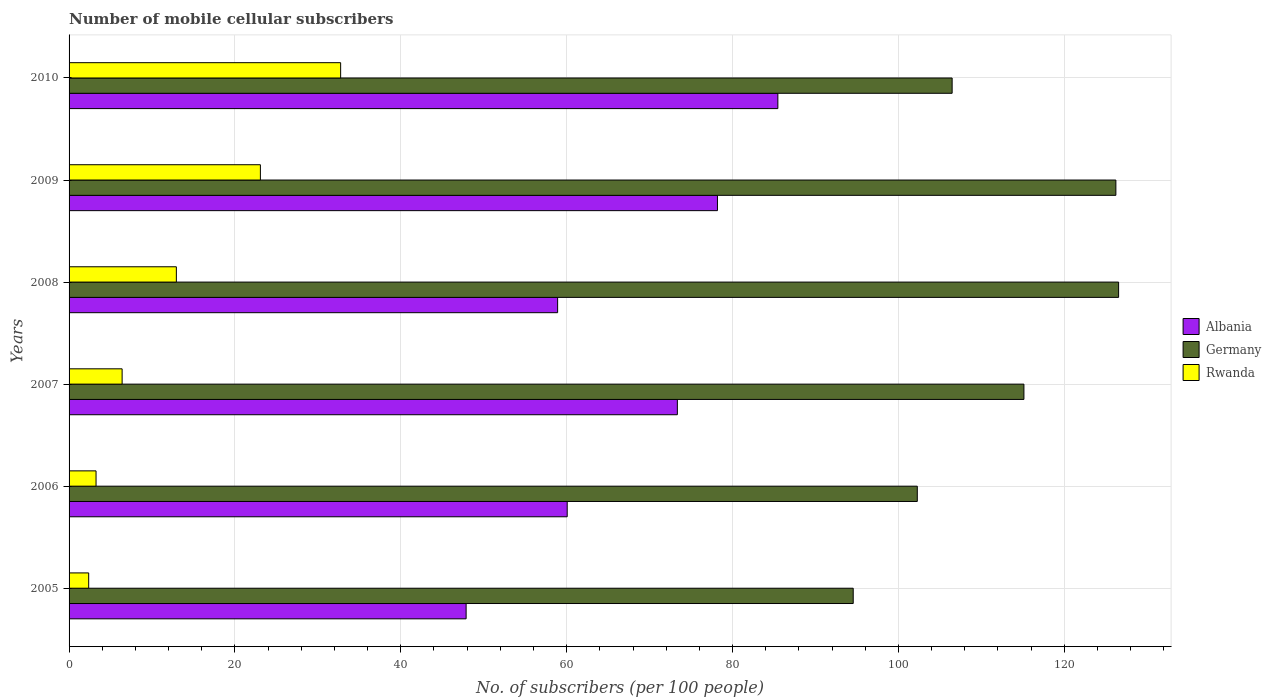How many different coloured bars are there?
Offer a terse response. 3. How many groups of bars are there?
Your response must be concise. 6. Are the number of bars per tick equal to the number of legend labels?
Offer a very short reply. Yes. Are the number of bars on each tick of the Y-axis equal?
Provide a short and direct response. Yes. What is the number of mobile cellular subscribers in Germany in 2009?
Offer a terse response. 126.23. Across all years, what is the maximum number of mobile cellular subscribers in Germany?
Keep it short and to the point. 126.56. Across all years, what is the minimum number of mobile cellular subscribers in Albania?
Your answer should be compact. 47.88. In which year was the number of mobile cellular subscribers in Germany maximum?
Offer a very short reply. 2008. In which year was the number of mobile cellular subscribers in Albania minimum?
Give a very brief answer. 2005. What is the total number of mobile cellular subscribers in Albania in the graph?
Provide a short and direct response. 403.86. What is the difference between the number of mobile cellular subscribers in Germany in 2007 and that in 2010?
Offer a very short reply. 8.66. What is the difference between the number of mobile cellular subscribers in Rwanda in 2006 and the number of mobile cellular subscribers in Albania in 2005?
Offer a terse response. -44.63. What is the average number of mobile cellular subscribers in Albania per year?
Your response must be concise. 67.31. In the year 2010, what is the difference between the number of mobile cellular subscribers in Albania and number of mobile cellular subscribers in Germany?
Your response must be concise. -21.02. In how many years, is the number of mobile cellular subscribers in Rwanda greater than 112 ?
Ensure brevity in your answer.  0. What is the ratio of the number of mobile cellular subscribers in Rwanda in 2008 to that in 2009?
Ensure brevity in your answer.  0.56. Is the difference between the number of mobile cellular subscribers in Albania in 2007 and 2008 greater than the difference between the number of mobile cellular subscribers in Germany in 2007 and 2008?
Ensure brevity in your answer.  Yes. What is the difference between the highest and the second highest number of mobile cellular subscribers in Germany?
Provide a short and direct response. 0.33. What is the difference between the highest and the lowest number of mobile cellular subscribers in Rwanda?
Offer a very short reply. 30.38. In how many years, is the number of mobile cellular subscribers in Albania greater than the average number of mobile cellular subscribers in Albania taken over all years?
Give a very brief answer. 3. What does the 2nd bar from the top in 2010 represents?
Make the answer very short. Germany. What does the 1st bar from the bottom in 2010 represents?
Ensure brevity in your answer.  Albania. Is it the case that in every year, the sum of the number of mobile cellular subscribers in Rwanda and number of mobile cellular subscribers in Albania is greater than the number of mobile cellular subscribers in Germany?
Give a very brief answer. No. What is the difference between two consecutive major ticks on the X-axis?
Offer a terse response. 20. Does the graph contain grids?
Your answer should be compact. Yes. Where does the legend appear in the graph?
Ensure brevity in your answer.  Center right. How many legend labels are there?
Provide a succinct answer. 3. What is the title of the graph?
Ensure brevity in your answer.  Number of mobile cellular subscribers. What is the label or title of the X-axis?
Provide a short and direct response. No. of subscribers (per 100 people). What is the label or title of the Y-axis?
Keep it short and to the point. Years. What is the No. of subscribers (per 100 people) in Albania in 2005?
Provide a succinct answer. 47.88. What is the No. of subscribers (per 100 people) of Germany in 2005?
Your answer should be compact. 94.55. What is the No. of subscribers (per 100 people) of Rwanda in 2005?
Provide a short and direct response. 2.36. What is the No. of subscribers (per 100 people) in Albania in 2006?
Your response must be concise. 60.07. What is the No. of subscribers (per 100 people) of Germany in 2006?
Your answer should be compact. 102.28. What is the No. of subscribers (per 100 people) of Rwanda in 2006?
Your answer should be very brief. 3.25. What is the No. of subscribers (per 100 people) of Albania in 2007?
Keep it short and to the point. 73.35. What is the No. of subscribers (per 100 people) of Germany in 2007?
Ensure brevity in your answer.  115.14. What is the No. of subscribers (per 100 people) in Rwanda in 2007?
Give a very brief answer. 6.4. What is the No. of subscribers (per 100 people) in Albania in 2008?
Ensure brevity in your answer.  58.91. What is the No. of subscribers (per 100 people) in Germany in 2008?
Offer a very short reply. 126.56. What is the No. of subscribers (per 100 people) in Rwanda in 2008?
Your answer should be compact. 12.94. What is the No. of subscribers (per 100 people) of Albania in 2009?
Provide a succinct answer. 78.18. What is the No. of subscribers (per 100 people) in Germany in 2009?
Give a very brief answer. 126.23. What is the No. of subscribers (per 100 people) in Rwanda in 2009?
Your response must be concise. 23.07. What is the No. of subscribers (per 100 people) of Albania in 2010?
Your answer should be compact. 85.47. What is the No. of subscribers (per 100 people) of Germany in 2010?
Give a very brief answer. 106.48. What is the No. of subscribers (per 100 people) of Rwanda in 2010?
Provide a short and direct response. 32.75. Across all years, what is the maximum No. of subscribers (per 100 people) of Albania?
Give a very brief answer. 85.47. Across all years, what is the maximum No. of subscribers (per 100 people) of Germany?
Your answer should be compact. 126.56. Across all years, what is the maximum No. of subscribers (per 100 people) in Rwanda?
Make the answer very short. 32.75. Across all years, what is the minimum No. of subscribers (per 100 people) in Albania?
Give a very brief answer. 47.88. Across all years, what is the minimum No. of subscribers (per 100 people) of Germany?
Offer a very short reply. 94.55. Across all years, what is the minimum No. of subscribers (per 100 people) in Rwanda?
Provide a short and direct response. 2.36. What is the total No. of subscribers (per 100 people) of Albania in the graph?
Make the answer very short. 403.86. What is the total No. of subscribers (per 100 people) in Germany in the graph?
Keep it short and to the point. 671.25. What is the total No. of subscribers (per 100 people) in Rwanda in the graph?
Give a very brief answer. 80.77. What is the difference between the No. of subscribers (per 100 people) of Albania in 2005 and that in 2006?
Offer a terse response. -12.19. What is the difference between the No. of subscribers (per 100 people) in Germany in 2005 and that in 2006?
Ensure brevity in your answer.  -7.73. What is the difference between the No. of subscribers (per 100 people) of Rwanda in 2005 and that in 2006?
Ensure brevity in your answer.  -0.89. What is the difference between the No. of subscribers (per 100 people) in Albania in 2005 and that in 2007?
Make the answer very short. -25.47. What is the difference between the No. of subscribers (per 100 people) in Germany in 2005 and that in 2007?
Offer a very short reply. -20.59. What is the difference between the No. of subscribers (per 100 people) of Rwanda in 2005 and that in 2007?
Offer a very short reply. -4.03. What is the difference between the No. of subscribers (per 100 people) of Albania in 2005 and that in 2008?
Provide a succinct answer. -11.03. What is the difference between the No. of subscribers (per 100 people) in Germany in 2005 and that in 2008?
Your answer should be compact. -32. What is the difference between the No. of subscribers (per 100 people) of Rwanda in 2005 and that in 2008?
Offer a very short reply. -10.57. What is the difference between the No. of subscribers (per 100 people) of Albania in 2005 and that in 2009?
Ensure brevity in your answer.  -30.31. What is the difference between the No. of subscribers (per 100 people) in Germany in 2005 and that in 2009?
Ensure brevity in your answer.  -31.67. What is the difference between the No. of subscribers (per 100 people) of Rwanda in 2005 and that in 2009?
Ensure brevity in your answer.  -20.71. What is the difference between the No. of subscribers (per 100 people) in Albania in 2005 and that in 2010?
Offer a terse response. -37.59. What is the difference between the No. of subscribers (per 100 people) of Germany in 2005 and that in 2010?
Your response must be concise. -11.93. What is the difference between the No. of subscribers (per 100 people) in Rwanda in 2005 and that in 2010?
Provide a short and direct response. -30.38. What is the difference between the No. of subscribers (per 100 people) in Albania in 2006 and that in 2007?
Your answer should be compact. -13.28. What is the difference between the No. of subscribers (per 100 people) in Germany in 2006 and that in 2007?
Keep it short and to the point. -12.86. What is the difference between the No. of subscribers (per 100 people) of Rwanda in 2006 and that in 2007?
Offer a terse response. -3.15. What is the difference between the No. of subscribers (per 100 people) in Albania in 2006 and that in 2008?
Ensure brevity in your answer.  1.16. What is the difference between the No. of subscribers (per 100 people) in Germany in 2006 and that in 2008?
Make the answer very short. -24.27. What is the difference between the No. of subscribers (per 100 people) in Rwanda in 2006 and that in 2008?
Provide a succinct answer. -9.69. What is the difference between the No. of subscribers (per 100 people) in Albania in 2006 and that in 2009?
Your answer should be very brief. -18.12. What is the difference between the No. of subscribers (per 100 people) of Germany in 2006 and that in 2009?
Give a very brief answer. -23.95. What is the difference between the No. of subscribers (per 100 people) in Rwanda in 2006 and that in 2009?
Ensure brevity in your answer.  -19.82. What is the difference between the No. of subscribers (per 100 people) of Albania in 2006 and that in 2010?
Offer a very short reply. -25.4. What is the difference between the No. of subscribers (per 100 people) in Germany in 2006 and that in 2010?
Offer a very short reply. -4.2. What is the difference between the No. of subscribers (per 100 people) of Rwanda in 2006 and that in 2010?
Offer a terse response. -29.5. What is the difference between the No. of subscribers (per 100 people) of Albania in 2007 and that in 2008?
Your answer should be very brief. 14.44. What is the difference between the No. of subscribers (per 100 people) of Germany in 2007 and that in 2008?
Make the answer very short. -11.42. What is the difference between the No. of subscribers (per 100 people) of Rwanda in 2007 and that in 2008?
Provide a short and direct response. -6.54. What is the difference between the No. of subscribers (per 100 people) of Albania in 2007 and that in 2009?
Your answer should be compact. -4.83. What is the difference between the No. of subscribers (per 100 people) of Germany in 2007 and that in 2009?
Provide a succinct answer. -11.09. What is the difference between the No. of subscribers (per 100 people) in Rwanda in 2007 and that in 2009?
Keep it short and to the point. -16.67. What is the difference between the No. of subscribers (per 100 people) in Albania in 2007 and that in 2010?
Keep it short and to the point. -12.12. What is the difference between the No. of subscribers (per 100 people) of Germany in 2007 and that in 2010?
Make the answer very short. 8.66. What is the difference between the No. of subscribers (per 100 people) in Rwanda in 2007 and that in 2010?
Ensure brevity in your answer.  -26.35. What is the difference between the No. of subscribers (per 100 people) of Albania in 2008 and that in 2009?
Your answer should be very brief. -19.27. What is the difference between the No. of subscribers (per 100 people) of Germany in 2008 and that in 2009?
Offer a very short reply. 0.33. What is the difference between the No. of subscribers (per 100 people) in Rwanda in 2008 and that in 2009?
Offer a terse response. -10.13. What is the difference between the No. of subscribers (per 100 people) of Albania in 2008 and that in 2010?
Your answer should be compact. -26.56. What is the difference between the No. of subscribers (per 100 people) in Germany in 2008 and that in 2010?
Provide a succinct answer. 20.07. What is the difference between the No. of subscribers (per 100 people) of Rwanda in 2008 and that in 2010?
Give a very brief answer. -19.81. What is the difference between the No. of subscribers (per 100 people) in Albania in 2009 and that in 2010?
Offer a very short reply. -7.28. What is the difference between the No. of subscribers (per 100 people) in Germany in 2009 and that in 2010?
Offer a terse response. 19.74. What is the difference between the No. of subscribers (per 100 people) of Rwanda in 2009 and that in 2010?
Keep it short and to the point. -9.68. What is the difference between the No. of subscribers (per 100 people) of Albania in 2005 and the No. of subscribers (per 100 people) of Germany in 2006?
Make the answer very short. -54.4. What is the difference between the No. of subscribers (per 100 people) in Albania in 2005 and the No. of subscribers (per 100 people) in Rwanda in 2006?
Your answer should be very brief. 44.63. What is the difference between the No. of subscribers (per 100 people) in Germany in 2005 and the No. of subscribers (per 100 people) in Rwanda in 2006?
Your answer should be very brief. 91.3. What is the difference between the No. of subscribers (per 100 people) of Albania in 2005 and the No. of subscribers (per 100 people) of Germany in 2007?
Ensure brevity in your answer.  -67.26. What is the difference between the No. of subscribers (per 100 people) in Albania in 2005 and the No. of subscribers (per 100 people) in Rwanda in 2007?
Your answer should be very brief. 41.48. What is the difference between the No. of subscribers (per 100 people) in Germany in 2005 and the No. of subscribers (per 100 people) in Rwanda in 2007?
Make the answer very short. 88.16. What is the difference between the No. of subscribers (per 100 people) of Albania in 2005 and the No. of subscribers (per 100 people) of Germany in 2008?
Make the answer very short. -78.68. What is the difference between the No. of subscribers (per 100 people) in Albania in 2005 and the No. of subscribers (per 100 people) in Rwanda in 2008?
Your answer should be very brief. 34.94. What is the difference between the No. of subscribers (per 100 people) of Germany in 2005 and the No. of subscribers (per 100 people) of Rwanda in 2008?
Keep it short and to the point. 81.62. What is the difference between the No. of subscribers (per 100 people) in Albania in 2005 and the No. of subscribers (per 100 people) in Germany in 2009?
Provide a succinct answer. -78.35. What is the difference between the No. of subscribers (per 100 people) of Albania in 2005 and the No. of subscribers (per 100 people) of Rwanda in 2009?
Give a very brief answer. 24.81. What is the difference between the No. of subscribers (per 100 people) in Germany in 2005 and the No. of subscribers (per 100 people) in Rwanda in 2009?
Your response must be concise. 71.48. What is the difference between the No. of subscribers (per 100 people) of Albania in 2005 and the No. of subscribers (per 100 people) of Germany in 2010?
Offer a very short reply. -58.61. What is the difference between the No. of subscribers (per 100 people) in Albania in 2005 and the No. of subscribers (per 100 people) in Rwanda in 2010?
Ensure brevity in your answer.  15.13. What is the difference between the No. of subscribers (per 100 people) in Germany in 2005 and the No. of subscribers (per 100 people) in Rwanda in 2010?
Make the answer very short. 61.81. What is the difference between the No. of subscribers (per 100 people) in Albania in 2006 and the No. of subscribers (per 100 people) in Germany in 2007?
Your answer should be very brief. -55.07. What is the difference between the No. of subscribers (per 100 people) of Albania in 2006 and the No. of subscribers (per 100 people) of Rwanda in 2007?
Offer a terse response. 53.67. What is the difference between the No. of subscribers (per 100 people) of Germany in 2006 and the No. of subscribers (per 100 people) of Rwanda in 2007?
Provide a short and direct response. 95.89. What is the difference between the No. of subscribers (per 100 people) of Albania in 2006 and the No. of subscribers (per 100 people) of Germany in 2008?
Keep it short and to the point. -66.49. What is the difference between the No. of subscribers (per 100 people) of Albania in 2006 and the No. of subscribers (per 100 people) of Rwanda in 2008?
Offer a very short reply. 47.13. What is the difference between the No. of subscribers (per 100 people) of Germany in 2006 and the No. of subscribers (per 100 people) of Rwanda in 2008?
Your answer should be very brief. 89.34. What is the difference between the No. of subscribers (per 100 people) of Albania in 2006 and the No. of subscribers (per 100 people) of Germany in 2009?
Ensure brevity in your answer.  -66.16. What is the difference between the No. of subscribers (per 100 people) in Albania in 2006 and the No. of subscribers (per 100 people) in Rwanda in 2009?
Provide a short and direct response. 37. What is the difference between the No. of subscribers (per 100 people) in Germany in 2006 and the No. of subscribers (per 100 people) in Rwanda in 2009?
Your answer should be compact. 79.21. What is the difference between the No. of subscribers (per 100 people) of Albania in 2006 and the No. of subscribers (per 100 people) of Germany in 2010?
Make the answer very short. -46.42. What is the difference between the No. of subscribers (per 100 people) in Albania in 2006 and the No. of subscribers (per 100 people) in Rwanda in 2010?
Offer a very short reply. 27.32. What is the difference between the No. of subscribers (per 100 people) in Germany in 2006 and the No. of subscribers (per 100 people) in Rwanda in 2010?
Keep it short and to the point. 69.54. What is the difference between the No. of subscribers (per 100 people) of Albania in 2007 and the No. of subscribers (per 100 people) of Germany in 2008?
Your answer should be compact. -53.21. What is the difference between the No. of subscribers (per 100 people) of Albania in 2007 and the No. of subscribers (per 100 people) of Rwanda in 2008?
Give a very brief answer. 60.41. What is the difference between the No. of subscribers (per 100 people) in Germany in 2007 and the No. of subscribers (per 100 people) in Rwanda in 2008?
Give a very brief answer. 102.2. What is the difference between the No. of subscribers (per 100 people) of Albania in 2007 and the No. of subscribers (per 100 people) of Germany in 2009?
Offer a terse response. -52.88. What is the difference between the No. of subscribers (per 100 people) of Albania in 2007 and the No. of subscribers (per 100 people) of Rwanda in 2009?
Your response must be concise. 50.28. What is the difference between the No. of subscribers (per 100 people) in Germany in 2007 and the No. of subscribers (per 100 people) in Rwanda in 2009?
Provide a short and direct response. 92.07. What is the difference between the No. of subscribers (per 100 people) of Albania in 2007 and the No. of subscribers (per 100 people) of Germany in 2010?
Provide a succinct answer. -33.13. What is the difference between the No. of subscribers (per 100 people) in Albania in 2007 and the No. of subscribers (per 100 people) in Rwanda in 2010?
Offer a very short reply. 40.6. What is the difference between the No. of subscribers (per 100 people) in Germany in 2007 and the No. of subscribers (per 100 people) in Rwanda in 2010?
Provide a succinct answer. 82.39. What is the difference between the No. of subscribers (per 100 people) of Albania in 2008 and the No. of subscribers (per 100 people) of Germany in 2009?
Your response must be concise. -67.32. What is the difference between the No. of subscribers (per 100 people) of Albania in 2008 and the No. of subscribers (per 100 people) of Rwanda in 2009?
Your answer should be very brief. 35.84. What is the difference between the No. of subscribers (per 100 people) of Germany in 2008 and the No. of subscribers (per 100 people) of Rwanda in 2009?
Give a very brief answer. 103.49. What is the difference between the No. of subscribers (per 100 people) in Albania in 2008 and the No. of subscribers (per 100 people) in Germany in 2010?
Give a very brief answer. -47.57. What is the difference between the No. of subscribers (per 100 people) of Albania in 2008 and the No. of subscribers (per 100 people) of Rwanda in 2010?
Keep it short and to the point. 26.16. What is the difference between the No. of subscribers (per 100 people) of Germany in 2008 and the No. of subscribers (per 100 people) of Rwanda in 2010?
Offer a terse response. 93.81. What is the difference between the No. of subscribers (per 100 people) in Albania in 2009 and the No. of subscribers (per 100 people) in Germany in 2010?
Your answer should be compact. -28.3. What is the difference between the No. of subscribers (per 100 people) in Albania in 2009 and the No. of subscribers (per 100 people) in Rwanda in 2010?
Provide a short and direct response. 45.44. What is the difference between the No. of subscribers (per 100 people) of Germany in 2009 and the No. of subscribers (per 100 people) of Rwanda in 2010?
Make the answer very short. 93.48. What is the average No. of subscribers (per 100 people) in Albania per year?
Make the answer very short. 67.31. What is the average No. of subscribers (per 100 people) of Germany per year?
Provide a short and direct response. 111.87. What is the average No. of subscribers (per 100 people) in Rwanda per year?
Offer a very short reply. 13.46. In the year 2005, what is the difference between the No. of subscribers (per 100 people) of Albania and No. of subscribers (per 100 people) of Germany?
Your answer should be compact. -46.68. In the year 2005, what is the difference between the No. of subscribers (per 100 people) in Albania and No. of subscribers (per 100 people) in Rwanda?
Ensure brevity in your answer.  45.51. In the year 2005, what is the difference between the No. of subscribers (per 100 people) in Germany and No. of subscribers (per 100 people) in Rwanda?
Provide a short and direct response. 92.19. In the year 2006, what is the difference between the No. of subscribers (per 100 people) of Albania and No. of subscribers (per 100 people) of Germany?
Your response must be concise. -42.22. In the year 2006, what is the difference between the No. of subscribers (per 100 people) of Albania and No. of subscribers (per 100 people) of Rwanda?
Provide a short and direct response. 56.82. In the year 2006, what is the difference between the No. of subscribers (per 100 people) in Germany and No. of subscribers (per 100 people) in Rwanda?
Your answer should be compact. 99.03. In the year 2007, what is the difference between the No. of subscribers (per 100 people) of Albania and No. of subscribers (per 100 people) of Germany?
Give a very brief answer. -41.79. In the year 2007, what is the difference between the No. of subscribers (per 100 people) of Albania and No. of subscribers (per 100 people) of Rwanda?
Keep it short and to the point. 66.95. In the year 2007, what is the difference between the No. of subscribers (per 100 people) of Germany and No. of subscribers (per 100 people) of Rwanda?
Your answer should be very brief. 108.74. In the year 2008, what is the difference between the No. of subscribers (per 100 people) in Albania and No. of subscribers (per 100 people) in Germany?
Your answer should be very brief. -67.65. In the year 2008, what is the difference between the No. of subscribers (per 100 people) in Albania and No. of subscribers (per 100 people) in Rwanda?
Make the answer very short. 45.97. In the year 2008, what is the difference between the No. of subscribers (per 100 people) of Germany and No. of subscribers (per 100 people) of Rwanda?
Offer a terse response. 113.62. In the year 2009, what is the difference between the No. of subscribers (per 100 people) in Albania and No. of subscribers (per 100 people) in Germany?
Offer a terse response. -48.04. In the year 2009, what is the difference between the No. of subscribers (per 100 people) of Albania and No. of subscribers (per 100 people) of Rwanda?
Your answer should be compact. 55.11. In the year 2009, what is the difference between the No. of subscribers (per 100 people) of Germany and No. of subscribers (per 100 people) of Rwanda?
Offer a very short reply. 103.16. In the year 2010, what is the difference between the No. of subscribers (per 100 people) in Albania and No. of subscribers (per 100 people) in Germany?
Provide a succinct answer. -21.02. In the year 2010, what is the difference between the No. of subscribers (per 100 people) of Albania and No. of subscribers (per 100 people) of Rwanda?
Your response must be concise. 52.72. In the year 2010, what is the difference between the No. of subscribers (per 100 people) of Germany and No. of subscribers (per 100 people) of Rwanda?
Your answer should be very brief. 73.74. What is the ratio of the No. of subscribers (per 100 people) in Albania in 2005 to that in 2006?
Provide a succinct answer. 0.8. What is the ratio of the No. of subscribers (per 100 people) of Germany in 2005 to that in 2006?
Make the answer very short. 0.92. What is the ratio of the No. of subscribers (per 100 people) of Rwanda in 2005 to that in 2006?
Your answer should be very brief. 0.73. What is the ratio of the No. of subscribers (per 100 people) of Albania in 2005 to that in 2007?
Your response must be concise. 0.65. What is the ratio of the No. of subscribers (per 100 people) of Germany in 2005 to that in 2007?
Your answer should be very brief. 0.82. What is the ratio of the No. of subscribers (per 100 people) in Rwanda in 2005 to that in 2007?
Offer a terse response. 0.37. What is the ratio of the No. of subscribers (per 100 people) of Albania in 2005 to that in 2008?
Make the answer very short. 0.81. What is the ratio of the No. of subscribers (per 100 people) of Germany in 2005 to that in 2008?
Offer a very short reply. 0.75. What is the ratio of the No. of subscribers (per 100 people) of Rwanda in 2005 to that in 2008?
Make the answer very short. 0.18. What is the ratio of the No. of subscribers (per 100 people) of Albania in 2005 to that in 2009?
Your response must be concise. 0.61. What is the ratio of the No. of subscribers (per 100 people) of Germany in 2005 to that in 2009?
Your answer should be compact. 0.75. What is the ratio of the No. of subscribers (per 100 people) of Rwanda in 2005 to that in 2009?
Keep it short and to the point. 0.1. What is the ratio of the No. of subscribers (per 100 people) of Albania in 2005 to that in 2010?
Make the answer very short. 0.56. What is the ratio of the No. of subscribers (per 100 people) of Germany in 2005 to that in 2010?
Give a very brief answer. 0.89. What is the ratio of the No. of subscribers (per 100 people) in Rwanda in 2005 to that in 2010?
Provide a succinct answer. 0.07. What is the ratio of the No. of subscribers (per 100 people) in Albania in 2006 to that in 2007?
Offer a very short reply. 0.82. What is the ratio of the No. of subscribers (per 100 people) in Germany in 2006 to that in 2007?
Your answer should be compact. 0.89. What is the ratio of the No. of subscribers (per 100 people) in Rwanda in 2006 to that in 2007?
Offer a very short reply. 0.51. What is the ratio of the No. of subscribers (per 100 people) of Albania in 2006 to that in 2008?
Provide a short and direct response. 1.02. What is the ratio of the No. of subscribers (per 100 people) in Germany in 2006 to that in 2008?
Offer a terse response. 0.81. What is the ratio of the No. of subscribers (per 100 people) in Rwanda in 2006 to that in 2008?
Your answer should be very brief. 0.25. What is the ratio of the No. of subscribers (per 100 people) in Albania in 2006 to that in 2009?
Ensure brevity in your answer.  0.77. What is the ratio of the No. of subscribers (per 100 people) of Germany in 2006 to that in 2009?
Your answer should be very brief. 0.81. What is the ratio of the No. of subscribers (per 100 people) of Rwanda in 2006 to that in 2009?
Your answer should be compact. 0.14. What is the ratio of the No. of subscribers (per 100 people) in Albania in 2006 to that in 2010?
Your response must be concise. 0.7. What is the ratio of the No. of subscribers (per 100 people) in Germany in 2006 to that in 2010?
Provide a short and direct response. 0.96. What is the ratio of the No. of subscribers (per 100 people) of Rwanda in 2006 to that in 2010?
Your answer should be compact. 0.1. What is the ratio of the No. of subscribers (per 100 people) in Albania in 2007 to that in 2008?
Provide a succinct answer. 1.25. What is the ratio of the No. of subscribers (per 100 people) of Germany in 2007 to that in 2008?
Offer a terse response. 0.91. What is the ratio of the No. of subscribers (per 100 people) in Rwanda in 2007 to that in 2008?
Your answer should be compact. 0.49. What is the ratio of the No. of subscribers (per 100 people) of Albania in 2007 to that in 2009?
Ensure brevity in your answer.  0.94. What is the ratio of the No. of subscribers (per 100 people) of Germany in 2007 to that in 2009?
Offer a terse response. 0.91. What is the ratio of the No. of subscribers (per 100 people) of Rwanda in 2007 to that in 2009?
Your answer should be very brief. 0.28. What is the ratio of the No. of subscribers (per 100 people) of Albania in 2007 to that in 2010?
Provide a short and direct response. 0.86. What is the ratio of the No. of subscribers (per 100 people) in Germany in 2007 to that in 2010?
Your answer should be very brief. 1.08. What is the ratio of the No. of subscribers (per 100 people) in Rwanda in 2007 to that in 2010?
Provide a succinct answer. 0.2. What is the ratio of the No. of subscribers (per 100 people) in Albania in 2008 to that in 2009?
Provide a succinct answer. 0.75. What is the ratio of the No. of subscribers (per 100 people) of Germany in 2008 to that in 2009?
Ensure brevity in your answer.  1. What is the ratio of the No. of subscribers (per 100 people) of Rwanda in 2008 to that in 2009?
Keep it short and to the point. 0.56. What is the ratio of the No. of subscribers (per 100 people) of Albania in 2008 to that in 2010?
Your answer should be very brief. 0.69. What is the ratio of the No. of subscribers (per 100 people) in Germany in 2008 to that in 2010?
Your answer should be very brief. 1.19. What is the ratio of the No. of subscribers (per 100 people) in Rwanda in 2008 to that in 2010?
Your answer should be very brief. 0.4. What is the ratio of the No. of subscribers (per 100 people) of Albania in 2009 to that in 2010?
Your response must be concise. 0.91. What is the ratio of the No. of subscribers (per 100 people) of Germany in 2009 to that in 2010?
Give a very brief answer. 1.19. What is the ratio of the No. of subscribers (per 100 people) of Rwanda in 2009 to that in 2010?
Offer a very short reply. 0.7. What is the difference between the highest and the second highest No. of subscribers (per 100 people) in Albania?
Make the answer very short. 7.28. What is the difference between the highest and the second highest No. of subscribers (per 100 people) in Germany?
Give a very brief answer. 0.33. What is the difference between the highest and the second highest No. of subscribers (per 100 people) in Rwanda?
Offer a terse response. 9.68. What is the difference between the highest and the lowest No. of subscribers (per 100 people) in Albania?
Offer a very short reply. 37.59. What is the difference between the highest and the lowest No. of subscribers (per 100 people) of Germany?
Offer a very short reply. 32. What is the difference between the highest and the lowest No. of subscribers (per 100 people) in Rwanda?
Make the answer very short. 30.38. 